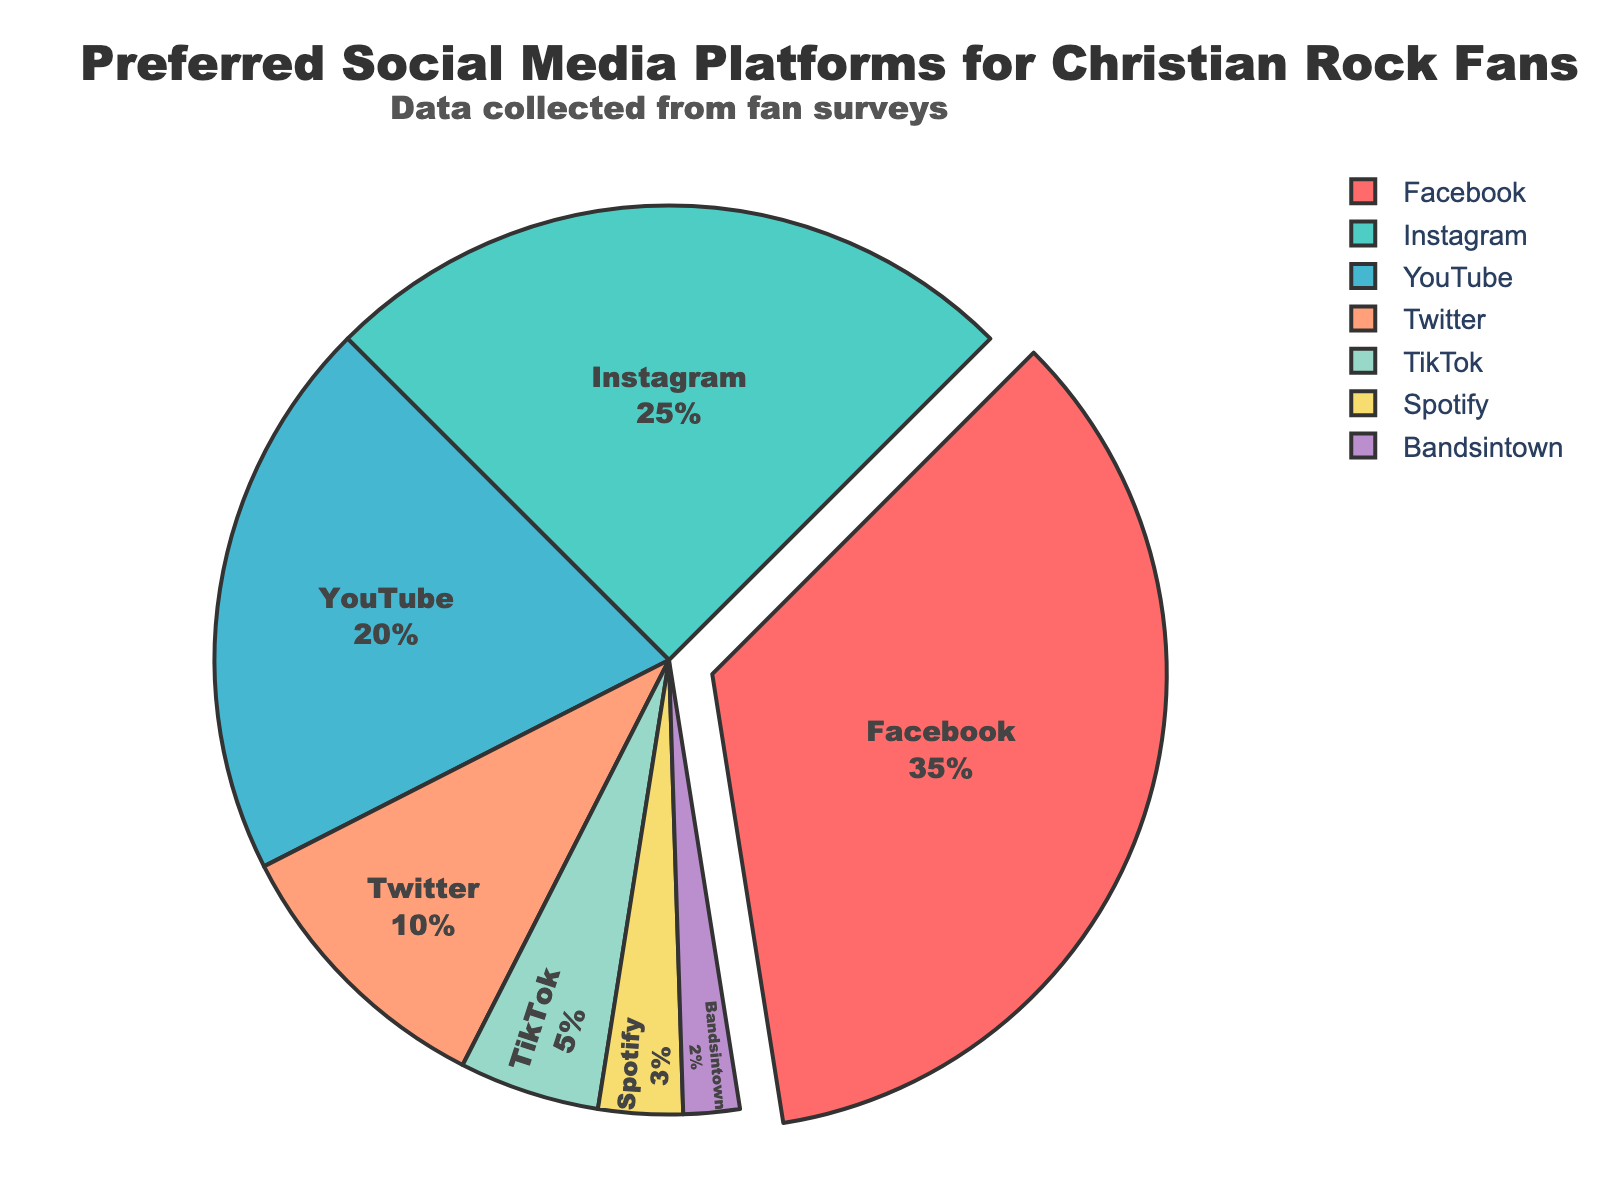Which social media platform is preferred the most by Christian Rock fans? The pie chart indicates that Facebook occupies the largest segment, indicating it is the most preferred social media platform for Christian Rock fans.
Answer: Facebook Which platform has more followers, Instagram or YouTube? By comparing the segments in the pie chart, it is clear that Instagram has a larger segment than YouTube.
Answer: Instagram What's the combined percentage of followers for Twitter, TikTok, and Spotify? Adding the percentages for Twitter (10%), TikTok (5%), and Spotify (3%) gives a total of 10 + 5 + 3 = 18.
Answer: 18% Which platform has the least followers? The smallest segment in the pie chart corresponds to Bandsintown, indicating it has the least followers.
Answer: Bandsintown Is Instagram preferred more than Twitter and TikTok combined? The pie chart shows Instagram at 25%, while the combined percentage for Twitter (10%) and TikTok (5%) is 15%. Since 25% is greater than 15%, Instagram is preferred more.
Answer: Yes How much more preferred is Facebook compared to TikTok? Facebook has 35% while TikTok has 5%. The difference is 35 - 5 = 30.
Answer: 30% Rank the social media platforms from most to least preferred based on the chart. By observing the sizes of the segments, the ranking from most to least preferred is: Facebook, Instagram, YouTube, Twitter, TikTok, Spotify, Bandsintown.
Answer: Facebook, Instagram, YouTube, Twitter, TikTok, Spotify, Bandsintown What is the average percentage of followers from the platforms Instagram, YouTube, and Twitter? Adding the percentages for Instagram (25%), YouTube (20%), and Twitter (10%) gives 25 + 20 + 10 = 55. Dividing by 3, the average is 55 / 3 ≈ 18.33.
Answer: 18.33% Which platforms together make up more than 50% of the followers? Checking cumulative segments: Facebook (35%) + Instagram (25%) = 60%. These platforms together make up more than 50%.
Answer: Facebook and Instagram 